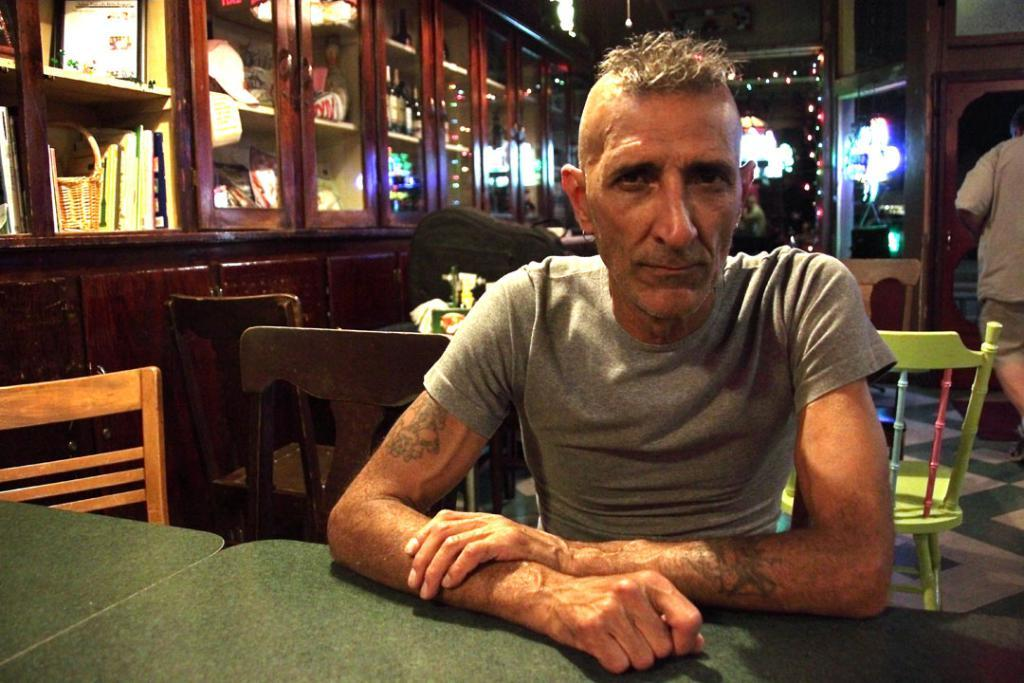What is the person in the image doing? There is a person sitting on a chair and another person walking in the image. What can be seen on the table? There are objects on the table in the image. How many chairs are visible in the image? There are chairs in the image. What is visible in the background? There are cupboards and a wall in the background of the image. What part of the room can be seen? The floor is visible in the image. What type of toad can be seen sitting on the chair in the image? There is no toad present in the image; it features a person sitting on a chair. What kind of beast is interacting with the person walking in the image? There is no beast present in the image; it only shows a person walking. 